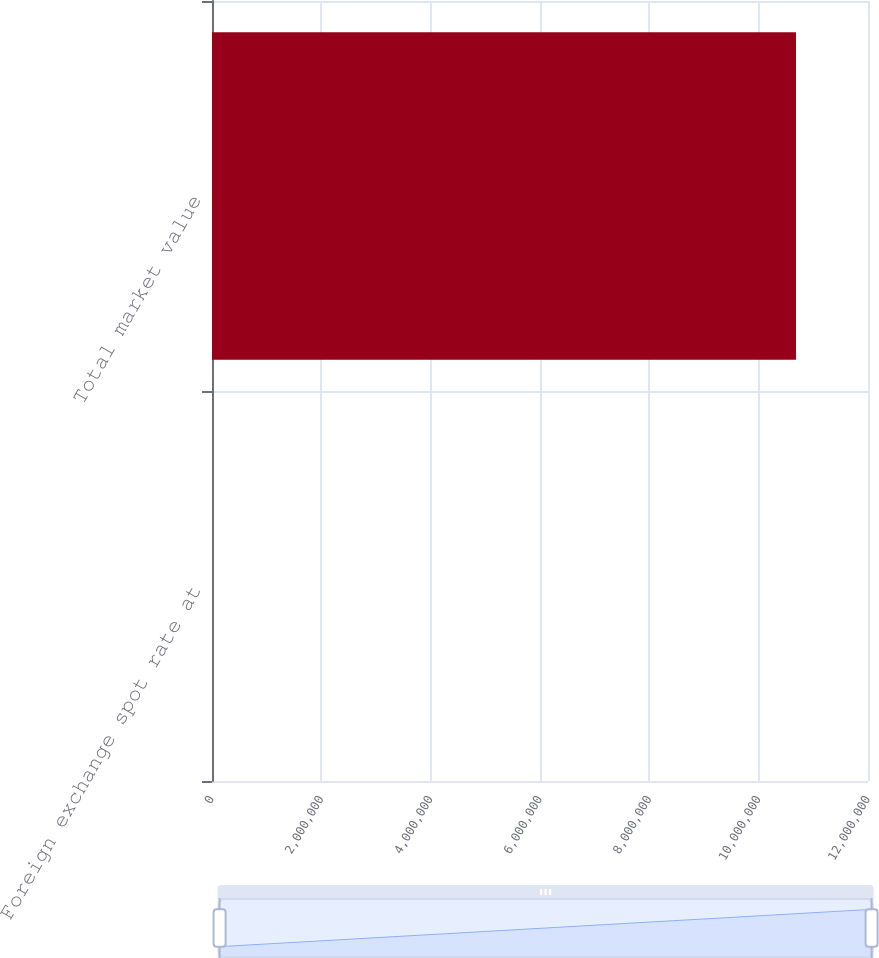Convert chart to OTSL. <chart><loc_0><loc_0><loc_500><loc_500><bar_chart><fcel>Foreign exchange spot rate at<fcel>Total market value<nl><fcel>5<fcel>1.06825e+07<nl></chart> 